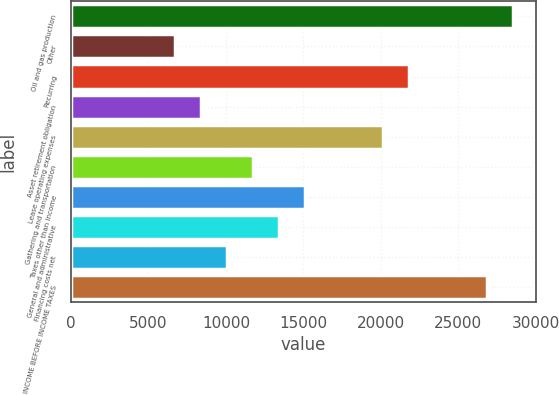Convert chart. <chart><loc_0><loc_0><loc_500><loc_500><bar_chart><fcel>Oil and gas production<fcel>Other<fcel>Recurring<fcel>Asset retirement obligation<fcel>Lease operating expenses<fcel>Gathering and transportation<fcel>Taxes other than income<fcel>General and administrative<fcel>Financing costs net<fcel>INCOME BEFORE INCOME TAXES<nl><fcel>28576.6<fcel>6724.36<fcel>21852.8<fcel>8405.3<fcel>20171.9<fcel>11767.2<fcel>15129.1<fcel>13448.1<fcel>10086.2<fcel>26895.6<nl></chart> 